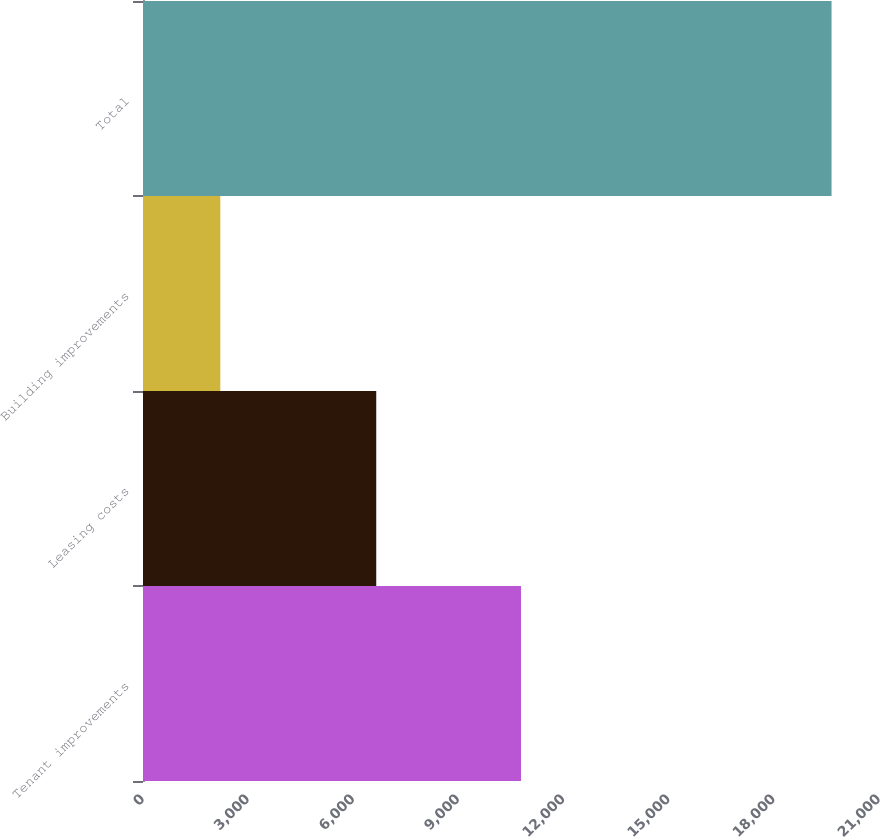<chart> <loc_0><loc_0><loc_500><loc_500><bar_chart><fcel>Tenant improvements<fcel>Leasing costs<fcel>Building improvements<fcel>Total<nl><fcel>10785<fcel>6655<fcel>2206<fcel>19646<nl></chart> 